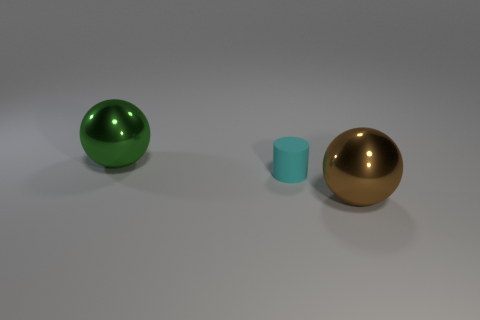Is there any other thing that is the same shape as the matte thing?
Your answer should be very brief. No. There is a large sphere that is to the left of the matte thing; how many brown shiny objects are behind it?
Your answer should be very brief. 0. There is a metal object to the left of the tiny object; are there any balls that are left of it?
Provide a short and direct response. No. There is a cyan thing; are there any cylinders behind it?
Give a very brief answer. No. There is a metallic thing that is behind the cyan matte object; does it have the same shape as the large brown metal object?
Give a very brief answer. Yes. What number of big brown things have the same shape as the large green object?
Offer a very short reply. 1. Is there a large green ball made of the same material as the cyan thing?
Your response must be concise. No. There is a large ball that is to the right of the large shiny object that is behind the matte object; what is its material?
Offer a very short reply. Metal. What size is the metal ball that is to the left of the brown thing?
Offer a very short reply. Large. Do the matte cylinder and the large metallic ball that is behind the small cyan rubber object have the same color?
Your response must be concise. No. 